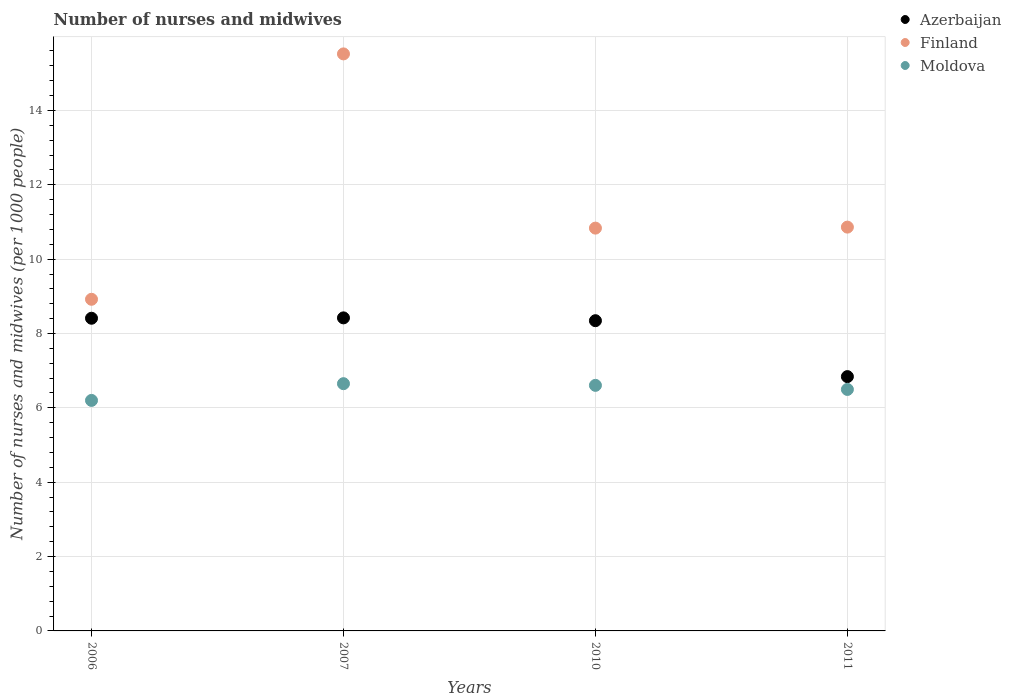What is the number of nurses and midwives in in Azerbaijan in 2010?
Offer a very short reply. 8.34. Across all years, what is the maximum number of nurses and midwives in in Moldova?
Your answer should be compact. 6.65. In which year was the number of nurses and midwives in in Moldova maximum?
Make the answer very short. 2007. In which year was the number of nurses and midwives in in Azerbaijan minimum?
Your answer should be very brief. 2011. What is the total number of nurses and midwives in in Moldova in the graph?
Ensure brevity in your answer.  25.95. What is the difference between the number of nurses and midwives in in Azerbaijan in 2010 and that in 2011?
Keep it short and to the point. 1.5. What is the difference between the number of nurses and midwives in in Azerbaijan in 2006 and the number of nurses and midwives in in Finland in 2010?
Provide a succinct answer. -2.42. What is the average number of nurses and midwives in in Azerbaijan per year?
Your answer should be very brief. 8. In the year 2011, what is the difference between the number of nurses and midwives in in Finland and number of nurses and midwives in in Azerbaijan?
Make the answer very short. 4.02. What is the ratio of the number of nurses and midwives in in Azerbaijan in 2006 to that in 2007?
Offer a terse response. 1. Is the number of nurses and midwives in in Finland in 2006 less than that in 2011?
Offer a very short reply. Yes. What is the difference between the highest and the second highest number of nurses and midwives in in Moldova?
Offer a very short reply. 0.04. What is the difference between the highest and the lowest number of nurses and midwives in in Moldova?
Make the answer very short. 0.45. Is the sum of the number of nurses and midwives in in Finland in 2006 and 2011 greater than the maximum number of nurses and midwives in in Azerbaijan across all years?
Offer a terse response. Yes. Is it the case that in every year, the sum of the number of nurses and midwives in in Azerbaijan and number of nurses and midwives in in Moldova  is greater than the number of nurses and midwives in in Finland?
Your answer should be very brief. No. Does the number of nurses and midwives in in Finland monotonically increase over the years?
Your response must be concise. No. How many dotlines are there?
Offer a very short reply. 3. Are the values on the major ticks of Y-axis written in scientific E-notation?
Provide a succinct answer. No. Does the graph contain grids?
Give a very brief answer. Yes. How are the legend labels stacked?
Provide a short and direct response. Vertical. What is the title of the graph?
Your answer should be compact. Number of nurses and midwives. Does "South Asia" appear as one of the legend labels in the graph?
Your answer should be compact. No. What is the label or title of the Y-axis?
Provide a succinct answer. Number of nurses and midwives (per 1000 people). What is the Number of nurses and midwives (per 1000 people) of Azerbaijan in 2006?
Ensure brevity in your answer.  8.41. What is the Number of nurses and midwives (per 1000 people) of Finland in 2006?
Your answer should be compact. 8.92. What is the Number of nurses and midwives (per 1000 people) in Moldova in 2006?
Offer a terse response. 6.2. What is the Number of nurses and midwives (per 1000 people) of Azerbaijan in 2007?
Offer a terse response. 8.42. What is the Number of nurses and midwives (per 1000 people) of Finland in 2007?
Offer a terse response. 15.52. What is the Number of nurses and midwives (per 1000 people) of Moldova in 2007?
Make the answer very short. 6.65. What is the Number of nurses and midwives (per 1000 people) in Azerbaijan in 2010?
Your answer should be very brief. 8.34. What is the Number of nurses and midwives (per 1000 people) of Finland in 2010?
Your response must be concise. 10.83. What is the Number of nurses and midwives (per 1000 people) of Moldova in 2010?
Your answer should be compact. 6.61. What is the Number of nurses and midwives (per 1000 people) in Azerbaijan in 2011?
Provide a short and direct response. 6.84. What is the Number of nurses and midwives (per 1000 people) of Finland in 2011?
Keep it short and to the point. 10.86. What is the Number of nurses and midwives (per 1000 people) of Moldova in 2011?
Your response must be concise. 6.5. Across all years, what is the maximum Number of nurses and midwives (per 1000 people) of Azerbaijan?
Provide a succinct answer. 8.42. Across all years, what is the maximum Number of nurses and midwives (per 1000 people) of Finland?
Provide a short and direct response. 15.52. Across all years, what is the maximum Number of nurses and midwives (per 1000 people) of Moldova?
Give a very brief answer. 6.65. Across all years, what is the minimum Number of nurses and midwives (per 1000 people) of Azerbaijan?
Your answer should be very brief. 6.84. Across all years, what is the minimum Number of nurses and midwives (per 1000 people) of Finland?
Provide a short and direct response. 8.92. Across all years, what is the minimum Number of nurses and midwives (per 1000 people) in Moldova?
Your answer should be very brief. 6.2. What is the total Number of nurses and midwives (per 1000 people) in Azerbaijan in the graph?
Give a very brief answer. 32.01. What is the total Number of nurses and midwives (per 1000 people) of Finland in the graph?
Provide a succinct answer. 46.13. What is the total Number of nurses and midwives (per 1000 people) in Moldova in the graph?
Provide a succinct answer. 25.95. What is the difference between the Number of nurses and midwives (per 1000 people) in Azerbaijan in 2006 and that in 2007?
Provide a succinct answer. -0.01. What is the difference between the Number of nurses and midwives (per 1000 people) in Finland in 2006 and that in 2007?
Your answer should be very brief. -6.6. What is the difference between the Number of nurses and midwives (per 1000 people) in Moldova in 2006 and that in 2007?
Make the answer very short. -0.45. What is the difference between the Number of nurses and midwives (per 1000 people) in Azerbaijan in 2006 and that in 2010?
Offer a terse response. 0.07. What is the difference between the Number of nurses and midwives (per 1000 people) in Finland in 2006 and that in 2010?
Provide a short and direct response. -1.91. What is the difference between the Number of nurses and midwives (per 1000 people) of Moldova in 2006 and that in 2010?
Provide a short and direct response. -0.41. What is the difference between the Number of nurses and midwives (per 1000 people) in Azerbaijan in 2006 and that in 2011?
Give a very brief answer. 1.57. What is the difference between the Number of nurses and midwives (per 1000 people) in Finland in 2006 and that in 2011?
Ensure brevity in your answer.  -1.94. What is the difference between the Number of nurses and midwives (per 1000 people) of Moldova in 2006 and that in 2011?
Give a very brief answer. -0.29. What is the difference between the Number of nurses and midwives (per 1000 people) of Azerbaijan in 2007 and that in 2010?
Make the answer very short. 0.08. What is the difference between the Number of nurses and midwives (per 1000 people) of Finland in 2007 and that in 2010?
Your response must be concise. 4.69. What is the difference between the Number of nurses and midwives (per 1000 people) of Moldova in 2007 and that in 2010?
Offer a terse response. 0.04. What is the difference between the Number of nurses and midwives (per 1000 people) of Azerbaijan in 2007 and that in 2011?
Your answer should be very brief. 1.58. What is the difference between the Number of nurses and midwives (per 1000 people) in Finland in 2007 and that in 2011?
Your answer should be compact. 4.66. What is the difference between the Number of nurses and midwives (per 1000 people) in Moldova in 2007 and that in 2011?
Keep it short and to the point. 0.15. What is the difference between the Number of nurses and midwives (per 1000 people) of Azerbaijan in 2010 and that in 2011?
Offer a very short reply. 1.5. What is the difference between the Number of nurses and midwives (per 1000 people) in Finland in 2010 and that in 2011?
Your response must be concise. -0.03. What is the difference between the Number of nurses and midwives (per 1000 people) of Moldova in 2010 and that in 2011?
Offer a terse response. 0.11. What is the difference between the Number of nurses and midwives (per 1000 people) in Azerbaijan in 2006 and the Number of nurses and midwives (per 1000 people) in Finland in 2007?
Offer a terse response. -7.11. What is the difference between the Number of nurses and midwives (per 1000 people) in Azerbaijan in 2006 and the Number of nurses and midwives (per 1000 people) in Moldova in 2007?
Give a very brief answer. 1.76. What is the difference between the Number of nurses and midwives (per 1000 people) of Finland in 2006 and the Number of nurses and midwives (per 1000 people) of Moldova in 2007?
Ensure brevity in your answer.  2.27. What is the difference between the Number of nurses and midwives (per 1000 people) of Azerbaijan in 2006 and the Number of nurses and midwives (per 1000 people) of Finland in 2010?
Provide a short and direct response. -2.42. What is the difference between the Number of nurses and midwives (per 1000 people) in Azerbaijan in 2006 and the Number of nurses and midwives (per 1000 people) in Moldova in 2010?
Make the answer very short. 1.8. What is the difference between the Number of nurses and midwives (per 1000 people) of Finland in 2006 and the Number of nurses and midwives (per 1000 people) of Moldova in 2010?
Make the answer very short. 2.31. What is the difference between the Number of nurses and midwives (per 1000 people) in Azerbaijan in 2006 and the Number of nurses and midwives (per 1000 people) in Finland in 2011?
Provide a succinct answer. -2.45. What is the difference between the Number of nurses and midwives (per 1000 people) in Azerbaijan in 2006 and the Number of nurses and midwives (per 1000 people) in Moldova in 2011?
Make the answer very short. 1.92. What is the difference between the Number of nurses and midwives (per 1000 people) in Finland in 2006 and the Number of nurses and midwives (per 1000 people) in Moldova in 2011?
Your answer should be very brief. 2.42. What is the difference between the Number of nurses and midwives (per 1000 people) of Azerbaijan in 2007 and the Number of nurses and midwives (per 1000 people) of Finland in 2010?
Your response must be concise. -2.41. What is the difference between the Number of nurses and midwives (per 1000 people) of Azerbaijan in 2007 and the Number of nurses and midwives (per 1000 people) of Moldova in 2010?
Provide a succinct answer. 1.81. What is the difference between the Number of nurses and midwives (per 1000 people) of Finland in 2007 and the Number of nurses and midwives (per 1000 people) of Moldova in 2010?
Your answer should be compact. 8.91. What is the difference between the Number of nurses and midwives (per 1000 people) of Azerbaijan in 2007 and the Number of nurses and midwives (per 1000 people) of Finland in 2011?
Offer a terse response. -2.44. What is the difference between the Number of nurses and midwives (per 1000 people) in Azerbaijan in 2007 and the Number of nurses and midwives (per 1000 people) in Moldova in 2011?
Offer a terse response. 1.93. What is the difference between the Number of nurses and midwives (per 1000 people) in Finland in 2007 and the Number of nurses and midwives (per 1000 people) in Moldova in 2011?
Offer a very short reply. 9.03. What is the difference between the Number of nurses and midwives (per 1000 people) in Azerbaijan in 2010 and the Number of nurses and midwives (per 1000 people) in Finland in 2011?
Offer a terse response. -2.52. What is the difference between the Number of nurses and midwives (per 1000 people) of Azerbaijan in 2010 and the Number of nurses and midwives (per 1000 people) of Moldova in 2011?
Your answer should be very brief. 1.85. What is the difference between the Number of nurses and midwives (per 1000 people) in Finland in 2010 and the Number of nurses and midwives (per 1000 people) in Moldova in 2011?
Your answer should be very brief. 4.34. What is the average Number of nurses and midwives (per 1000 people) of Azerbaijan per year?
Provide a short and direct response. 8. What is the average Number of nurses and midwives (per 1000 people) in Finland per year?
Make the answer very short. 11.53. What is the average Number of nurses and midwives (per 1000 people) in Moldova per year?
Your answer should be compact. 6.49. In the year 2006, what is the difference between the Number of nurses and midwives (per 1000 people) in Azerbaijan and Number of nurses and midwives (per 1000 people) in Finland?
Ensure brevity in your answer.  -0.51. In the year 2006, what is the difference between the Number of nurses and midwives (per 1000 people) of Azerbaijan and Number of nurses and midwives (per 1000 people) of Moldova?
Provide a short and direct response. 2.21. In the year 2006, what is the difference between the Number of nurses and midwives (per 1000 people) in Finland and Number of nurses and midwives (per 1000 people) in Moldova?
Your answer should be compact. 2.72. In the year 2007, what is the difference between the Number of nurses and midwives (per 1000 people) of Azerbaijan and Number of nurses and midwives (per 1000 people) of Moldova?
Your response must be concise. 1.77. In the year 2007, what is the difference between the Number of nurses and midwives (per 1000 people) of Finland and Number of nurses and midwives (per 1000 people) of Moldova?
Ensure brevity in your answer.  8.87. In the year 2010, what is the difference between the Number of nurses and midwives (per 1000 people) in Azerbaijan and Number of nurses and midwives (per 1000 people) in Finland?
Offer a terse response. -2.49. In the year 2010, what is the difference between the Number of nurses and midwives (per 1000 people) in Azerbaijan and Number of nurses and midwives (per 1000 people) in Moldova?
Keep it short and to the point. 1.74. In the year 2010, what is the difference between the Number of nurses and midwives (per 1000 people) of Finland and Number of nurses and midwives (per 1000 people) of Moldova?
Your response must be concise. 4.23. In the year 2011, what is the difference between the Number of nurses and midwives (per 1000 people) of Azerbaijan and Number of nurses and midwives (per 1000 people) of Finland?
Your answer should be compact. -4.02. In the year 2011, what is the difference between the Number of nurses and midwives (per 1000 people) of Azerbaijan and Number of nurses and midwives (per 1000 people) of Moldova?
Provide a short and direct response. 0.34. In the year 2011, what is the difference between the Number of nurses and midwives (per 1000 people) of Finland and Number of nurses and midwives (per 1000 people) of Moldova?
Your answer should be very brief. 4.37. What is the ratio of the Number of nurses and midwives (per 1000 people) of Finland in 2006 to that in 2007?
Offer a very short reply. 0.57. What is the ratio of the Number of nurses and midwives (per 1000 people) of Moldova in 2006 to that in 2007?
Make the answer very short. 0.93. What is the ratio of the Number of nurses and midwives (per 1000 people) of Azerbaijan in 2006 to that in 2010?
Make the answer very short. 1.01. What is the ratio of the Number of nurses and midwives (per 1000 people) in Finland in 2006 to that in 2010?
Offer a very short reply. 0.82. What is the ratio of the Number of nurses and midwives (per 1000 people) of Moldova in 2006 to that in 2010?
Provide a short and direct response. 0.94. What is the ratio of the Number of nurses and midwives (per 1000 people) of Azerbaijan in 2006 to that in 2011?
Offer a very short reply. 1.23. What is the ratio of the Number of nurses and midwives (per 1000 people) of Finland in 2006 to that in 2011?
Your answer should be very brief. 0.82. What is the ratio of the Number of nurses and midwives (per 1000 people) in Moldova in 2006 to that in 2011?
Your answer should be compact. 0.95. What is the ratio of the Number of nurses and midwives (per 1000 people) in Azerbaijan in 2007 to that in 2010?
Provide a short and direct response. 1.01. What is the ratio of the Number of nurses and midwives (per 1000 people) of Finland in 2007 to that in 2010?
Your answer should be compact. 1.43. What is the ratio of the Number of nurses and midwives (per 1000 people) in Moldova in 2007 to that in 2010?
Keep it short and to the point. 1.01. What is the ratio of the Number of nurses and midwives (per 1000 people) of Azerbaijan in 2007 to that in 2011?
Provide a succinct answer. 1.23. What is the ratio of the Number of nurses and midwives (per 1000 people) in Finland in 2007 to that in 2011?
Keep it short and to the point. 1.43. What is the ratio of the Number of nurses and midwives (per 1000 people) of Moldova in 2007 to that in 2011?
Your answer should be very brief. 1.02. What is the ratio of the Number of nurses and midwives (per 1000 people) of Azerbaijan in 2010 to that in 2011?
Give a very brief answer. 1.22. What is the ratio of the Number of nurses and midwives (per 1000 people) of Moldova in 2010 to that in 2011?
Make the answer very short. 1.02. What is the difference between the highest and the second highest Number of nurses and midwives (per 1000 people) of Finland?
Your response must be concise. 4.66. What is the difference between the highest and the second highest Number of nurses and midwives (per 1000 people) of Moldova?
Provide a short and direct response. 0.04. What is the difference between the highest and the lowest Number of nurses and midwives (per 1000 people) in Azerbaijan?
Offer a very short reply. 1.58. What is the difference between the highest and the lowest Number of nurses and midwives (per 1000 people) of Moldova?
Your response must be concise. 0.45. 